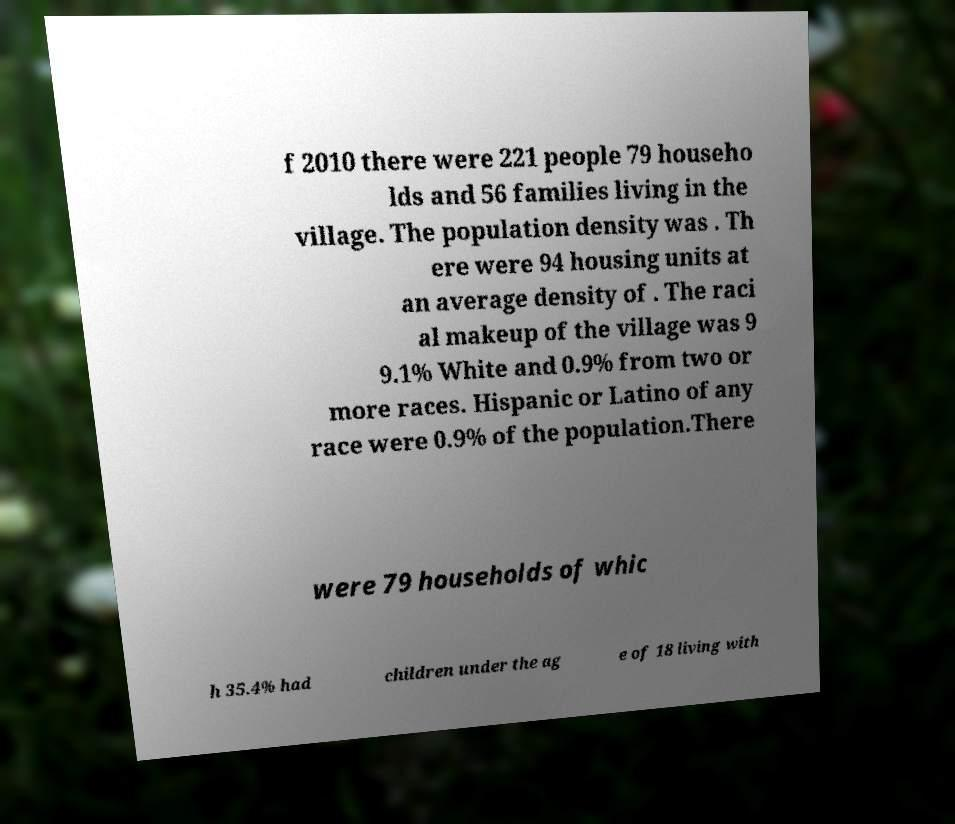Please identify and transcribe the text found in this image. f 2010 there were 221 people 79 househo lds and 56 families living in the village. The population density was . Th ere were 94 housing units at an average density of . The raci al makeup of the village was 9 9.1% White and 0.9% from two or more races. Hispanic or Latino of any race were 0.9% of the population.There were 79 households of whic h 35.4% had children under the ag e of 18 living with 